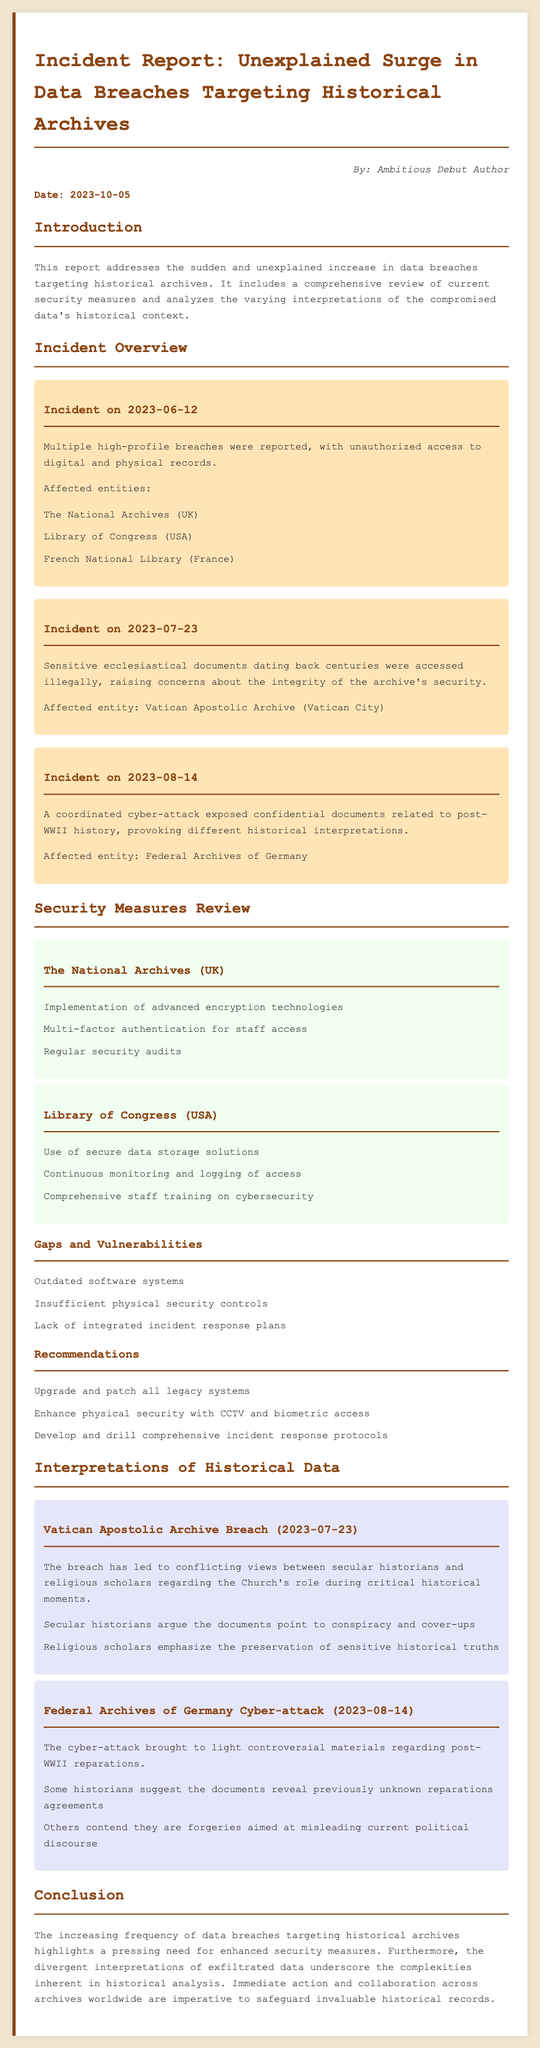what was the date of the first incident? The first incident is listed as occurring on June 12, 2023.
Answer: June 12, 2023 which organization was affected by the cyber-attack on August 14, 2023? The document states that the affected entity for this incident is the Federal Archives of Germany.
Answer: Federal Archives of Germany what security measure is used by the Library of Congress? The document lists the use of secure data storage solutions as a security measure for the Library of Congress.
Answer: Secure data storage solutions what are the gaps and vulnerabilities mentioned in the report? The report lists outdated software systems, insufficient physical security controls, and lack of integrated incident response plans as gaps.
Answer: Outdated software systems, insufficient physical security controls, lack of integrated incident response plans how did secular historians interpret the Vatican Apostolic Archive breach? Secular historians argue the documents point to conspiracy and cover-ups according to the report.
Answer: Conspiracy and cover-ups what is the main concern highlighted in the conclusion of the report? The conclusion emphasizes the need for enhanced security measures for historical archives.
Answer: Enhanced security measures 